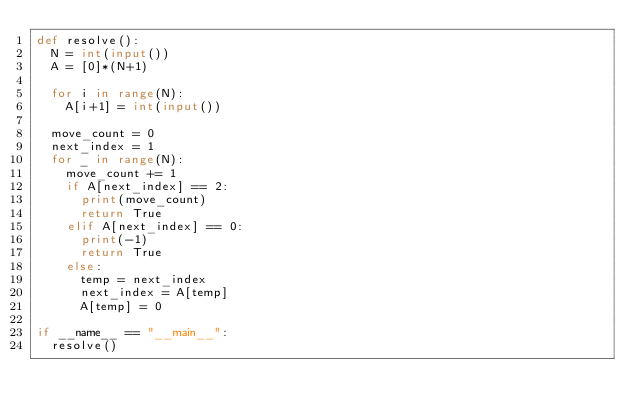<code> <loc_0><loc_0><loc_500><loc_500><_Python_>def resolve():
  N = int(input())
  A = [0]*(N+1)

  for i in range(N):
    A[i+1] = int(input())

  move_count = 0
  next_index = 1
  for _ in range(N):
    move_count += 1
    if A[next_index] == 2:
      print(move_count)
      return True
    elif A[next_index] == 0:
      print(-1)
      return True
    else:
      temp = next_index
      next_index = A[temp]
      A[temp] = 0

if __name__ == "__main__":
  resolve()</code> 